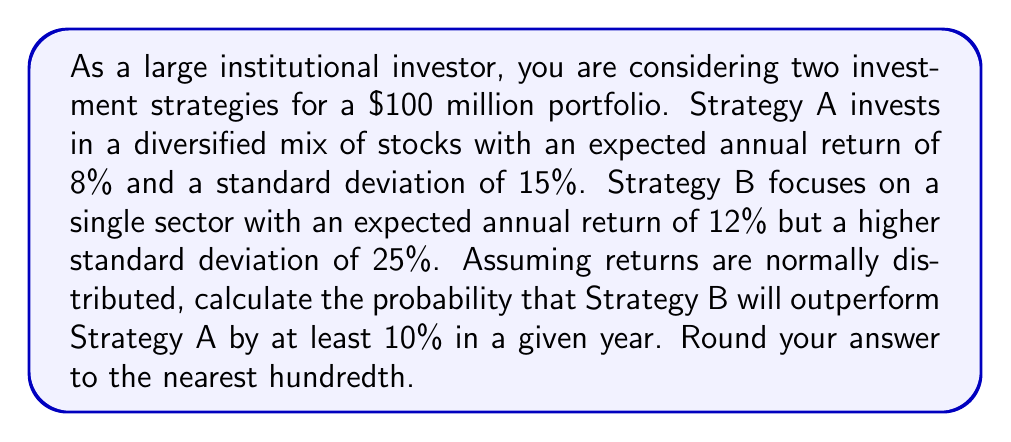Solve this math problem. To solve this problem, we'll follow these steps:

1. Define the random variables for each strategy's return.
2. Calculate the difference between the two strategies' returns.
3. Standardize the difference to find the z-score.
4. Use the z-table to find the probability.

Step 1: Define the random variables
Let $X_A$ be the return for Strategy A and $X_B$ be the return for Strategy B.
$X_A \sim N(0.08, 0.15^2)$
$X_B \sim N(0.12, 0.25^2)$

Step 2: Calculate the difference
We want to find $P(X_B - X_A \geq 0.10)$
The difference $X_B - X_A$ is also normally distributed with:
$E[X_B - X_A] = E[X_B] - E[X_A] = 0.12 - 0.08 = 0.04$
$Var(X_B - X_A) = Var(X_B) + Var(X_A) = 0.25^2 + 0.15^2 = 0.0850$
$SD(X_B - X_A) = \sqrt{0.0850} \approx 0.2915$

Step 3: Standardize the difference
We need to find the z-score for the difference of 0.10:
$$z = \frac{0.10 - 0.04}{0.2915} \approx 0.2058$$

Step 4: Use the z-table
We want the probability that $X_B - X_A$ is greater than 0.10, which is equivalent to the probability that a standard normal variable is greater than 0.2058.

Using a z-table or standard normal distribution calculator, we find:
$P(Z > 0.2058) \approx 0.4185$

Therefore, the probability that Strategy B will outperform Strategy A by at least 10% in a given year is approximately 0.4185 or 41.85%.
Answer: 0.42 (rounded to the nearest hundredth) 